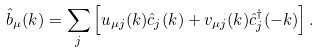<formula> <loc_0><loc_0><loc_500><loc_500>\hat { b } _ { \mu } ( k ) = \sum _ { j } \left [ u _ { \mu j } ( k ) \hat { c } _ { j } ( k ) + v _ { \mu j } ( k ) \hat { c } ^ { \dag } _ { j } ( - k ) \right ] .</formula> 